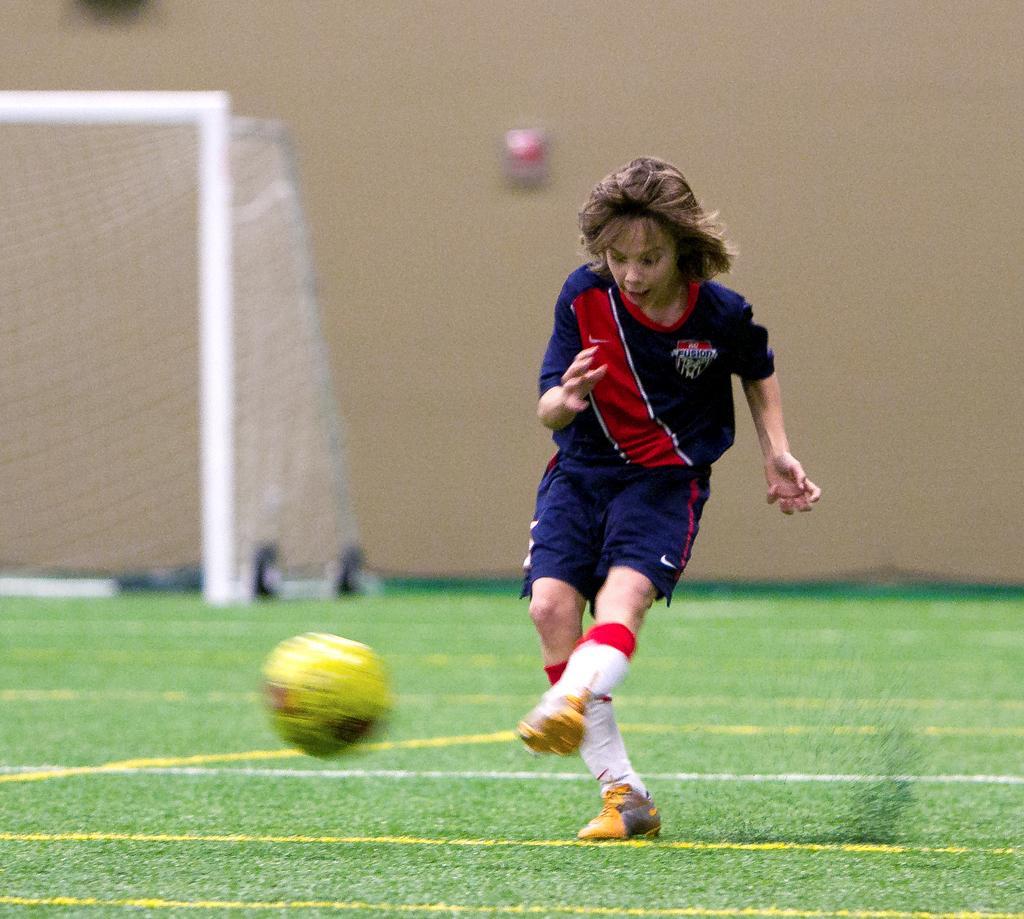Describe this image in one or two sentences. In this image there is a person playing foot ball in the ground, behind him there is a goalkeeper pole and net. 